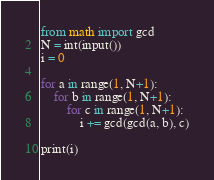<code> <loc_0><loc_0><loc_500><loc_500><_Python_>from math import gcd 
N = int(input())
i = 0
 
for a in range(1, N+1):
    for b in range(1, N+1):
        for c in range(1, N+1):
            i += gcd(gcd(a, b), c)
            
print(i)
</code> 